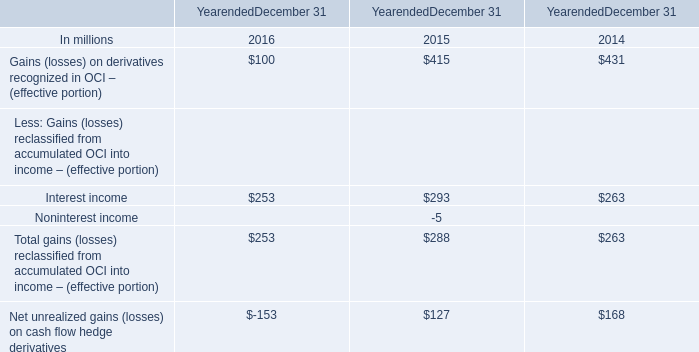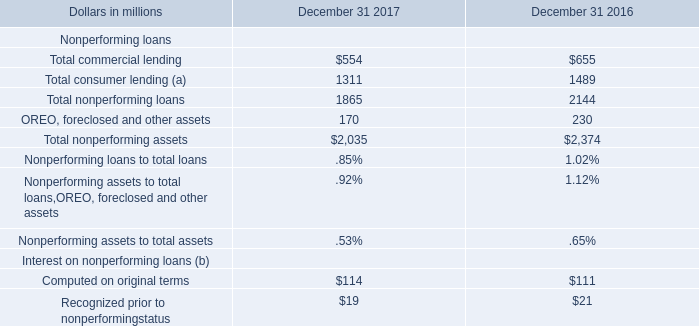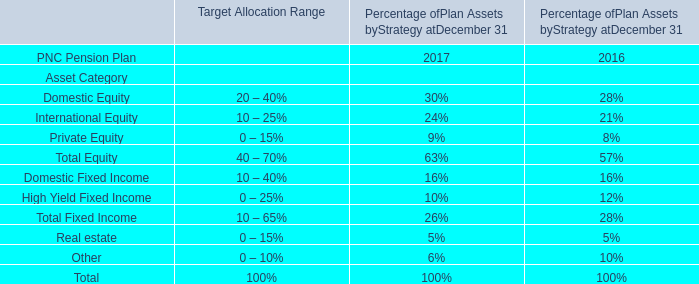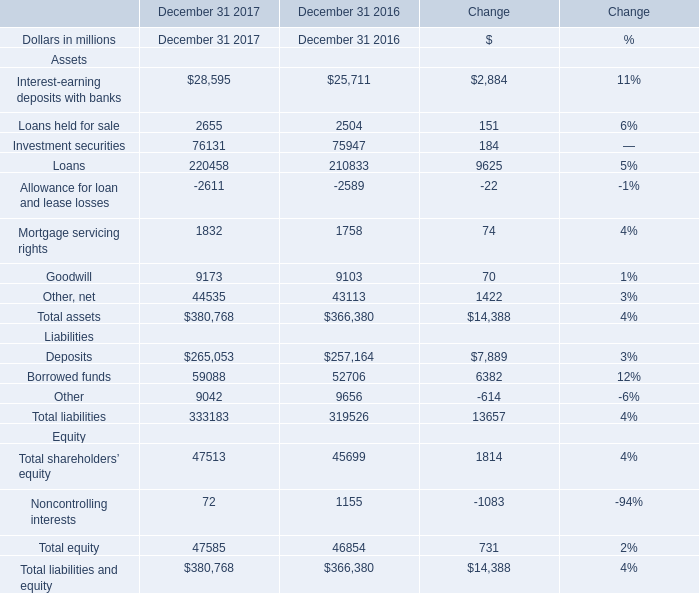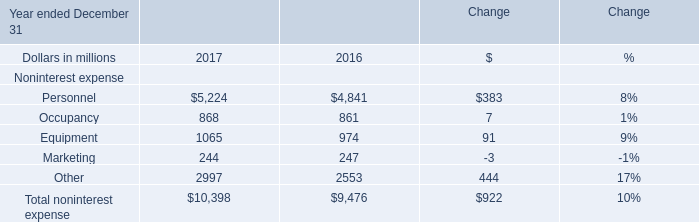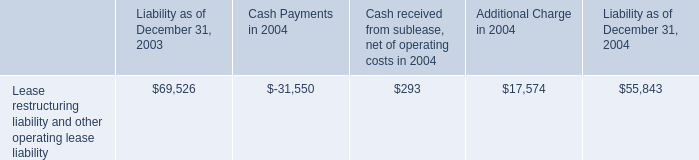Does Personnel keeps increasing each year between 2016 and 2017? 
Answer: yes. 